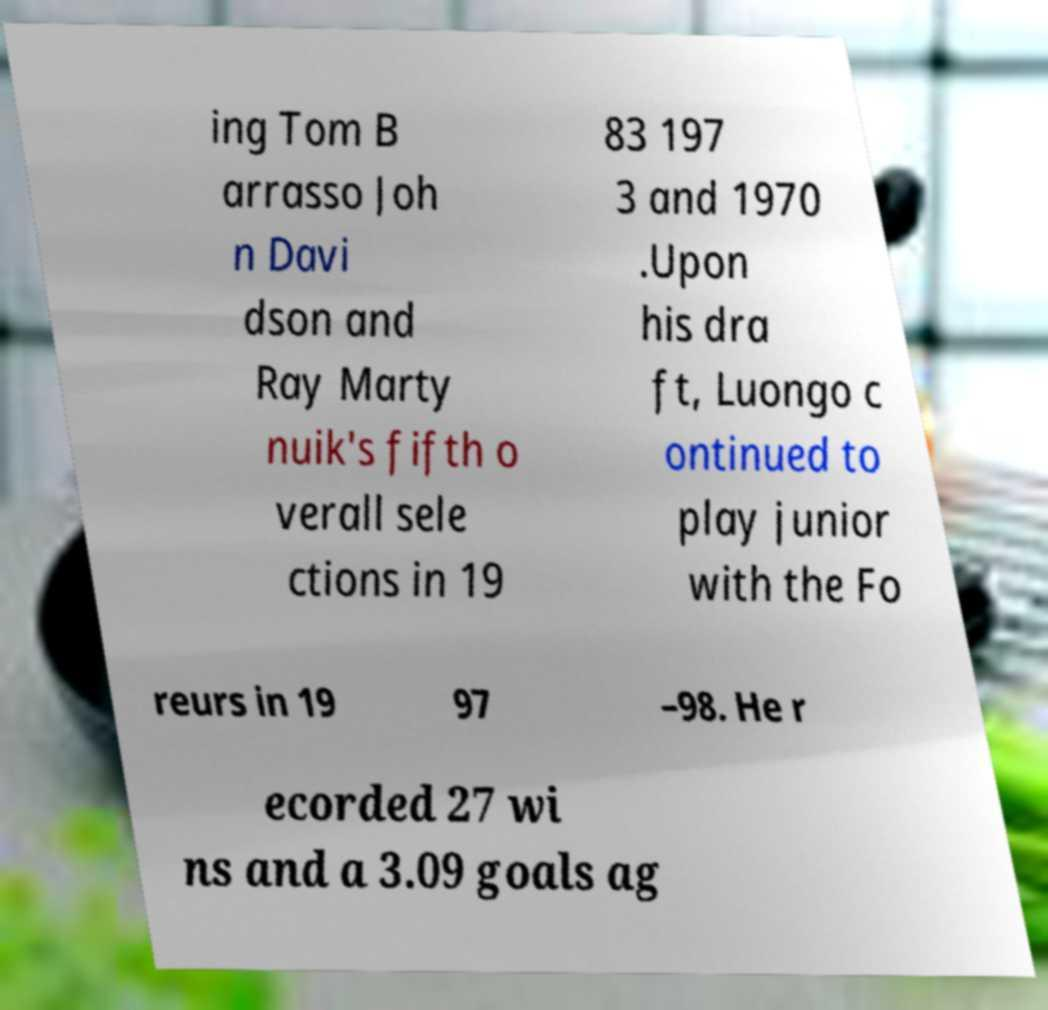Please identify and transcribe the text found in this image. ing Tom B arrasso Joh n Davi dson and Ray Marty nuik's fifth o verall sele ctions in 19 83 197 3 and 1970 .Upon his dra ft, Luongo c ontinued to play junior with the Fo reurs in 19 97 –98. He r ecorded 27 wi ns and a 3.09 goals ag 